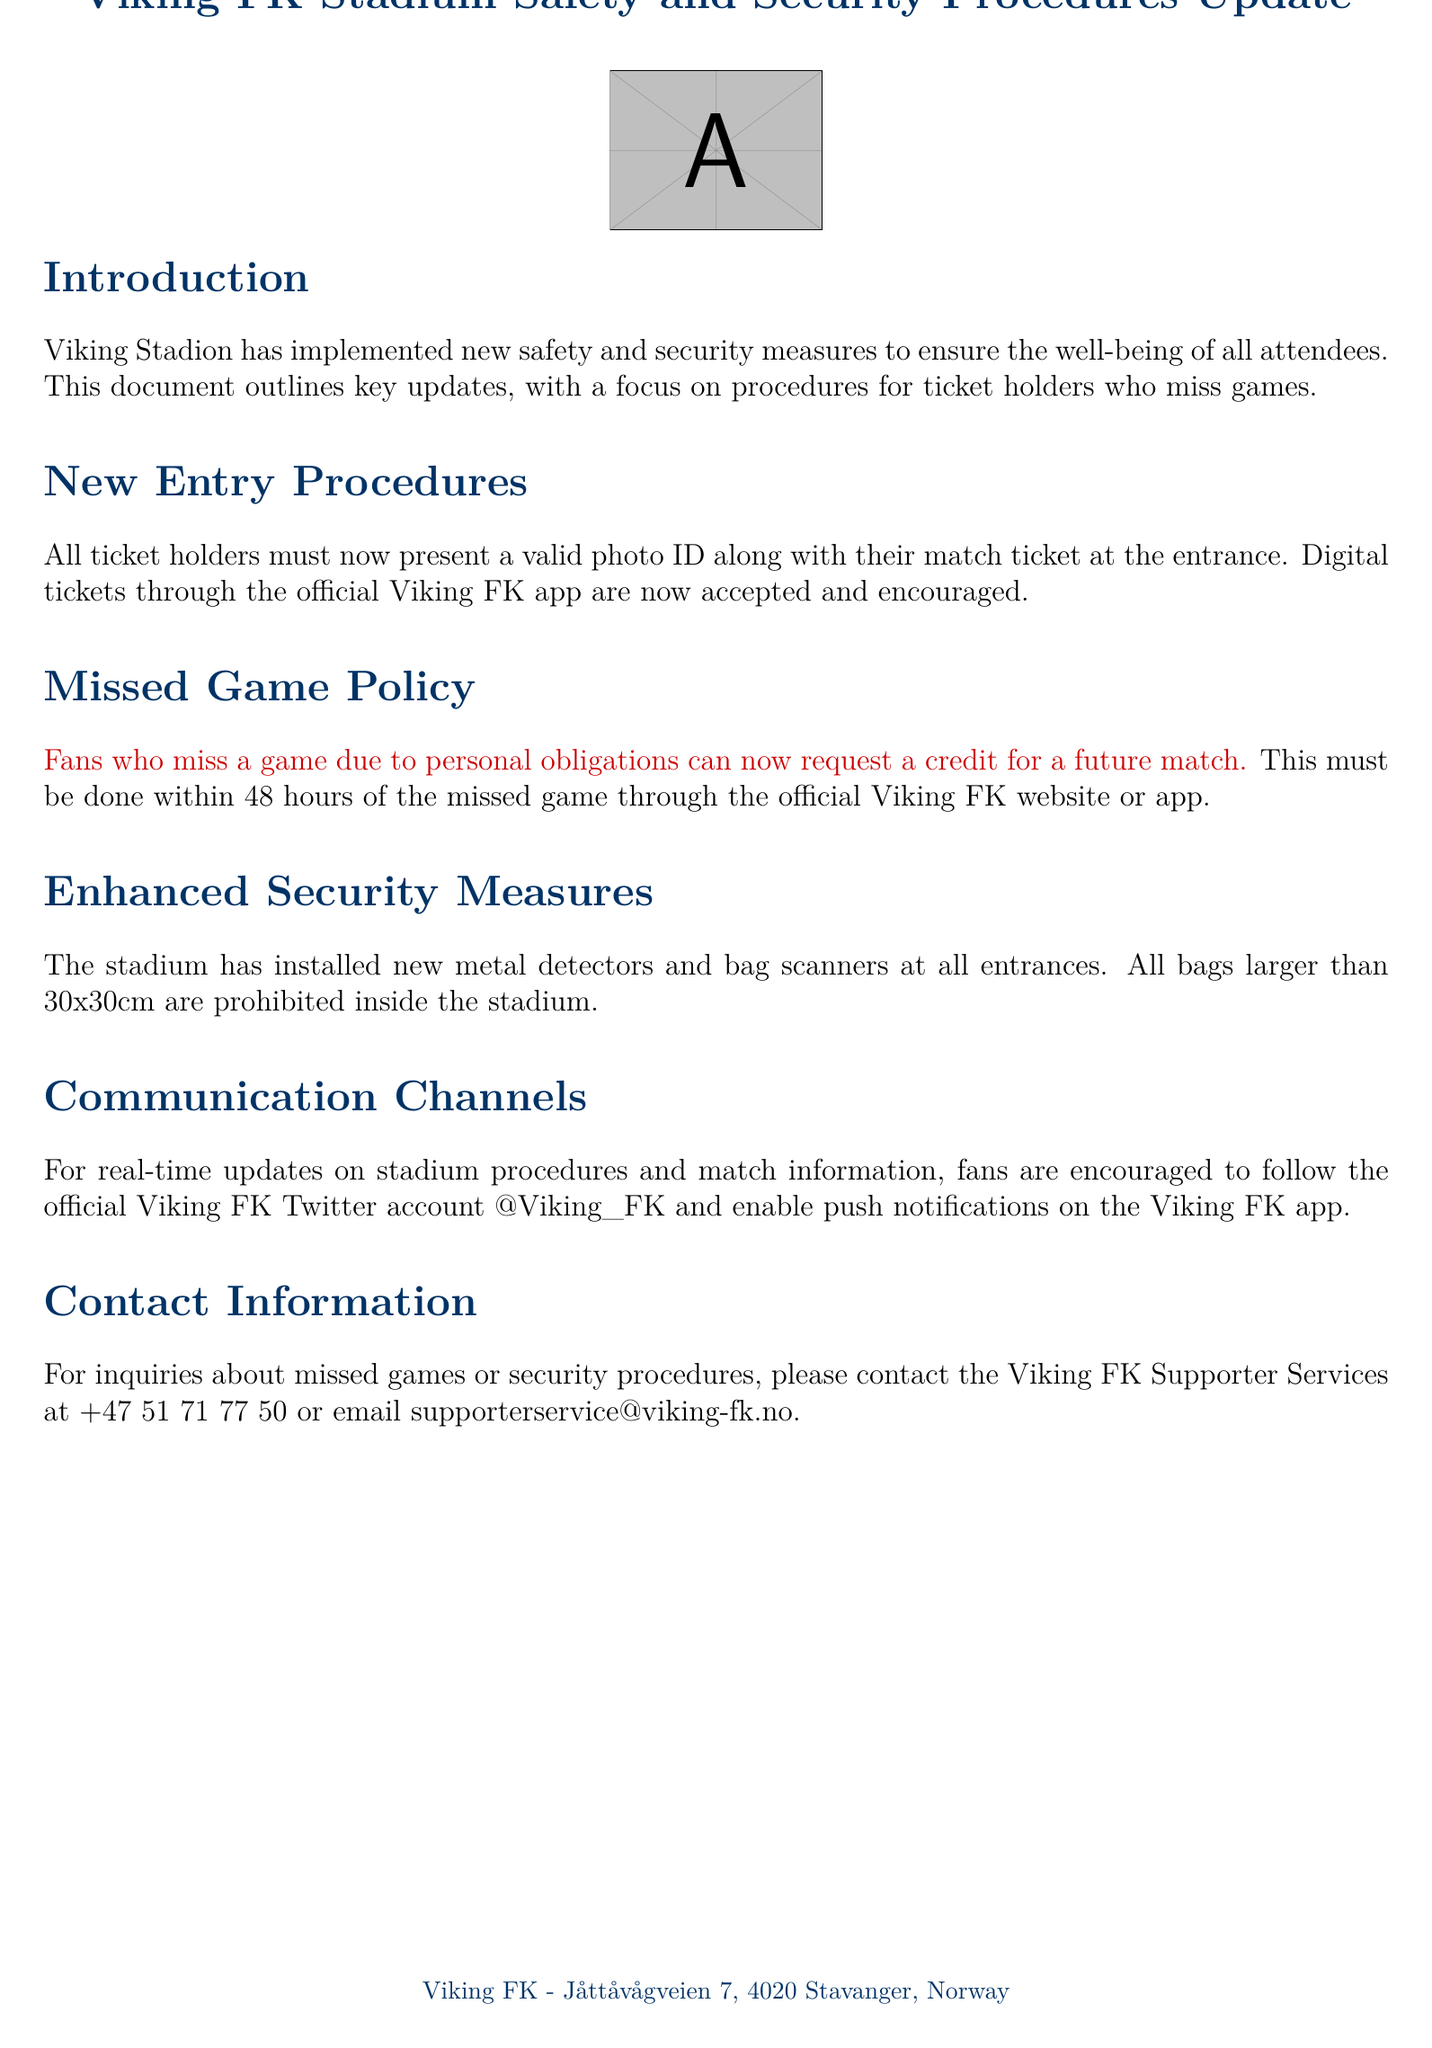What is the purpose of the document? The document outlines key updates regarding safety and security measures at Viking Stadion, focusing on procedures for ticket holders who miss games.
Answer: Updated safety and security procedures What must ticket holders present at the entrance? Ticket holders are required to show a valid photo ID along with their match ticket for entry into the stadium.
Answer: Valid photo ID and match ticket What can fans request if they miss a game? Fans who miss a game due to personal obligations can request a credit for a future match through the official website or app.
Answer: Credit for a future match How long do fans have to request a credit after missing a game? Fans must make a request within 48 hours of missing the game to be eligible for a credit.
Answer: 48 hours What are the new security measures at the stadium? The stadium has implemented new metal detectors and bag scanners at all entrances to enhance security.
Answer: Metal detectors and bag scanners What size bags are prohibited inside the stadium? Any bags larger than 30x30cm are not allowed to be taken into the stadium for security reasons.
Answer: Larger than 30x30cm How can fans receive real-time updates from Viking FK? Fans can follow the official Viking FK Twitter account and enable push notifications on the Viking FK app for real-time updates.
Answer: Twitter account and app notifications What is the contact number for Viking FK Supporter Services? The contact number for inquiries related to missed games or security procedures is provided in the document.
Answer: +47 51 71 77 50 